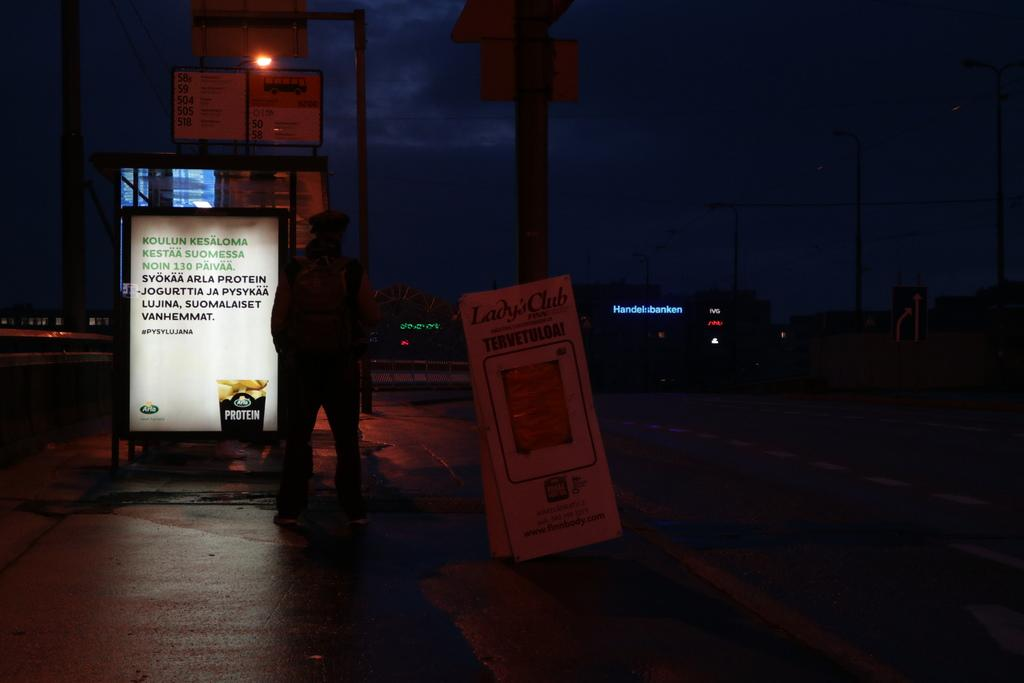What can be seen on the left side of the image? There is a person standing on the left side of the image. What is written or displayed in the image? There are words visible in the image. What type of pathway is present in the image? There is a road in the image. What is the source of light in the image? There is a street light in the image. What is visible at the top of the image? The sky is visible at the top of the image. Can you see any marks on the person's forehead in the image? There is no mention of any marks on the person's forehead in the image. What type of flame is present in the image? There is no flame present in the image. 